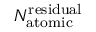<formula> <loc_0><loc_0><loc_500><loc_500>N _ { a t o m i c } ^ { r e s i d u a l }</formula> 